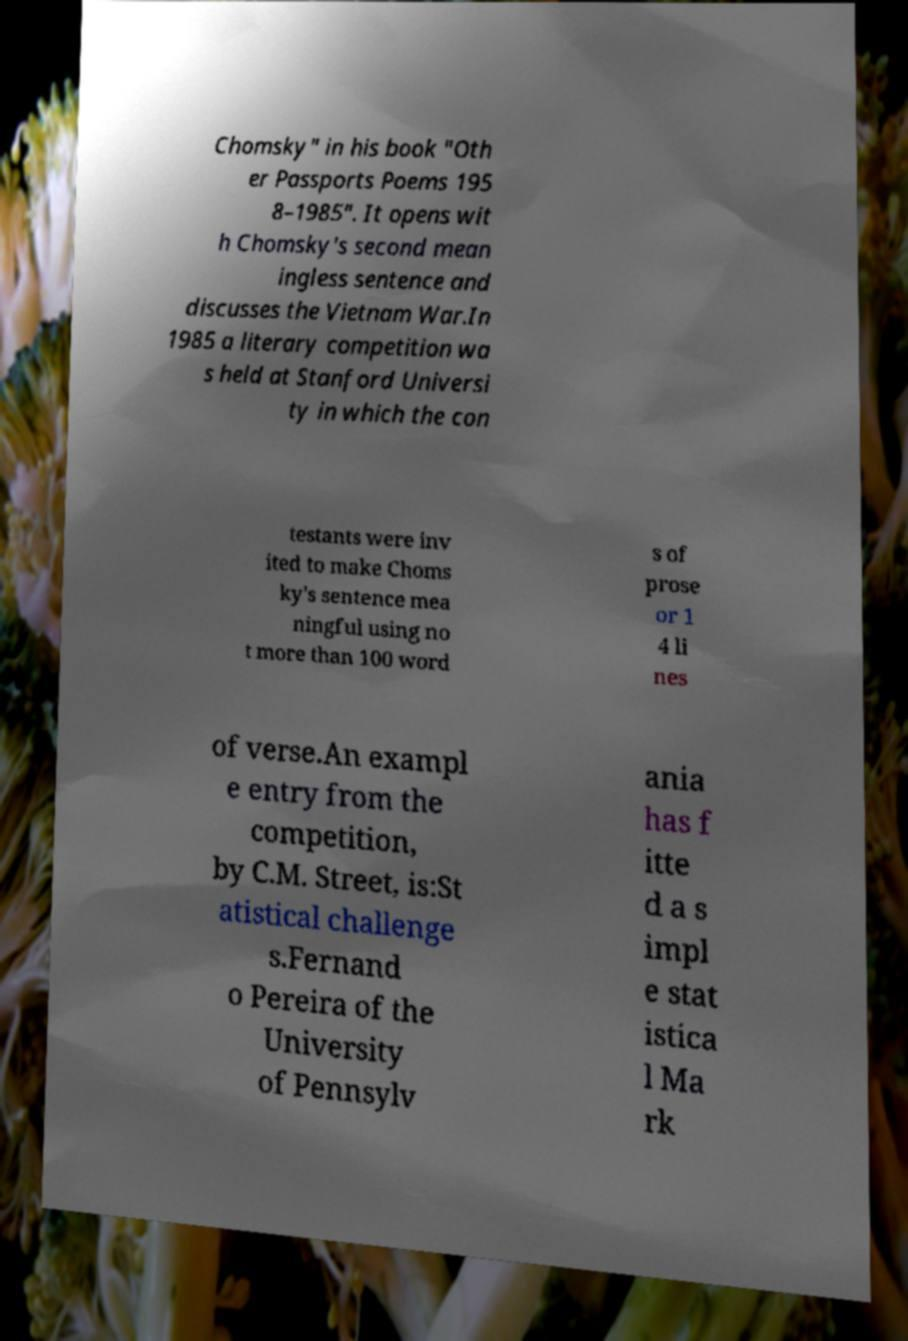Please read and relay the text visible in this image. What does it say? Chomsky" in his book "Oth er Passports Poems 195 8–1985". It opens wit h Chomsky's second mean ingless sentence and discusses the Vietnam War.In 1985 a literary competition wa s held at Stanford Universi ty in which the con testants were inv ited to make Choms ky's sentence mea ningful using no t more than 100 word s of prose or 1 4 li nes of verse.An exampl e entry from the competition, by C.M. Street, is:St atistical challenge s.Fernand o Pereira of the University of Pennsylv ania has f itte d a s impl e stat istica l Ma rk 